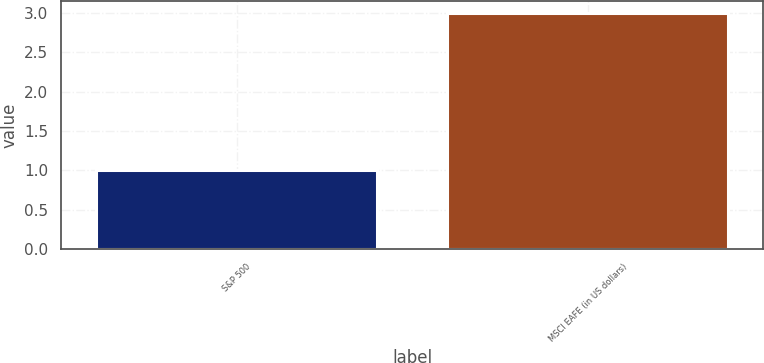Convert chart to OTSL. <chart><loc_0><loc_0><loc_500><loc_500><bar_chart><fcel>S&P 500<fcel>MSCI EAFE (in US dollars)<nl><fcel>1<fcel>3<nl></chart> 